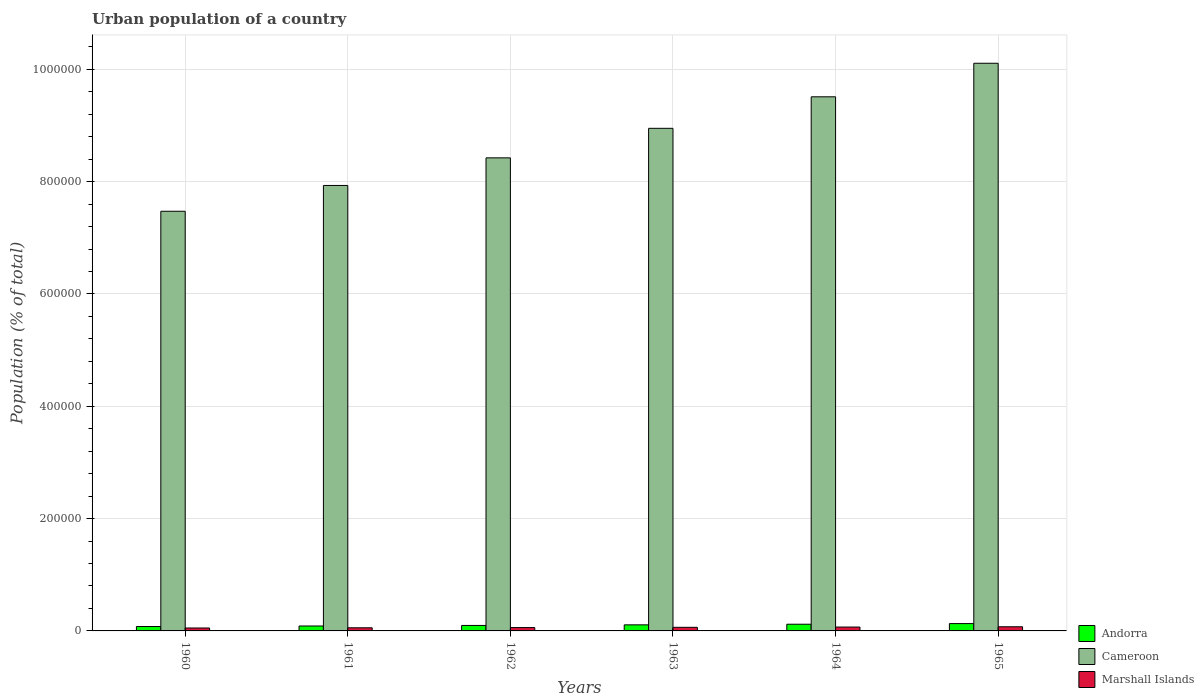How many different coloured bars are there?
Your response must be concise. 3. How many groups of bars are there?
Provide a short and direct response. 6. Are the number of bars per tick equal to the number of legend labels?
Provide a short and direct response. Yes. What is the urban population in Marshall Islands in 1963?
Ensure brevity in your answer.  6408. Across all years, what is the maximum urban population in Andorra?
Your answer should be compact. 1.31e+04. Across all years, what is the minimum urban population in Marshall Islands?
Your answer should be very brief. 5218. In which year was the urban population in Marshall Islands maximum?
Your answer should be compact. 1965. What is the total urban population in Cameroon in the graph?
Offer a very short reply. 5.24e+06. What is the difference between the urban population in Andorra in 1961 and that in 1965?
Keep it short and to the point. -4301. What is the difference between the urban population in Marshall Islands in 1962 and the urban population in Cameroon in 1963?
Offer a terse response. -8.89e+05. What is the average urban population in Andorra per year?
Your answer should be very brief. 1.04e+04. In the year 1961, what is the difference between the urban population in Cameroon and urban population in Marshall Islands?
Make the answer very short. 7.88e+05. In how many years, is the urban population in Andorra greater than 760000 %?
Provide a short and direct response. 0. What is the ratio of the urban population in Marshall Islands in 1960 to that in 1965?
Your response must be concise. 0.71. Is the difference between the urban population in Cameroon in 1962 and 1965 greater than the difference between the urban population in Marshall Islands in 1962 and 1965?
Keep it short and to the point. No. What is the difference between the highest and the second highest urban population in Cameroon?
Ensure brevity in your answer.  5.97e+04. What is the difference between the highest and the lowest urban population in Andorra?
Give a very brief answer. 5228. What does the 3rd bar from the left in 1965 represents?
Provide a short and direct response. Marshall Islands. What does the 2nd bar from the right in 1960 represents?
Your response must be concise. Cameroon. How many years are there in the graph?
Give a very brief answer. 6. What is the difference between two consecutive major ticks on the Y-axis?
Provide a succinct answer. 2.00e+05. Does the graph contain any zero values?
Offer a very short reply. No. Does the graph contain grids?
Your response must be concise. Yes. How many legend labels are there?
Provide a succinct answer. 3. What is the title of the graph?
Make the answer very short. Urban population of a country. What is the label or title of the X-axis?
Offer a very short reply. Years. What is the label or title of the Y-axis?
Your answer should be compact. Population (% of total). What is the Population (% of total) of Andorra in 1960?
Your response must be concise. 7840. What is the Population (% of total) in Cameroon in 1960?
Provide a short and direct response. 7.47e+05. What is the Population (% of total) in Marshall Islands in 1960?
Provide a succinct answer. 5218. What is the Population (% of total) in Andorra in 1961?
Provide a short and direct response. 8767. What is the Population (% of total) in Cameroon in 1961?
Provide a short and direct response. 7.93e+05. What is the Population (% of total) in Marshall Islands in 1961?
Offer a terse response. 5563. What is the Population (% of total) in Andorra in 1962?
Offer a very short reply. 9758. What is the Population (% of total) in Cameroon in 1962?
Keep it short and to the point. 8.42e+05. What is the Population (% of total) in Marshall Islands in 1962?
Your answer should be compact. 5963. What is the Population (% of total) of Andorra in 1963?
Ensure brevity in your answer.  1.08e+04. What is the Population (% of total) of Cameroon in 1963?
Your answer should be compact. 8.95e+05. What is the Population (% of total) in Marshall Islands in 1963?
Make the answer very short. 6408. What is the Population (% of total) of Andorra in 1964?
Your response must be concise. 1.19e+04. What is the Population (% of total) of Cameroon in 1964?
Make the answer very short. 9.51e+05. What is the Population (% of total) in Marshall Islands in 1964?
Provide a short and direct response. 6884. What is the Population (% of total) in Andorra in 1965?
Your response must be concise. 1.31e+04. What is the Population (% of total) of Cameroon in 1965?
Give a very brief answer. 1.01e+06. What is the Population (% of total) in Marshall Islands in 1965?
Your answer should be compact. 7373. Across all years, what is the maximum Population (% of total) in Andorra?
Your answer should be compact. 1.31e+04. Across all years, what is the maximum Population (% of total) of Cameroon?
Give a very brief answer. 1.01e+06. Across all years, what is the maximum Population (% of total) in Marshall Islands?
Provide a short and direct response. 7373. Across all years, what is the minimum Population (% of total) in Andorra?
Ensure brevity in your answer.  7840. Across all years, what is the minimum Population (% of total) of Cameroon?
Your answer should be very brief. 7.47e+05. Across all years, what is the minimum Population (% of total) of Marshall Islands?
Provide a succinct answer. 5218. What is the total Population (% of total) in Andorra in the graph?
Your answer should be very brief. 6.22e+04. What is the total Population (% of total) in Cameroon in the graph?
Your response must be concise. 5.24e+06. What is the total Population (% of total) in Marshall Islands in the graph?
Your answer should be very brief. 3.74e+04. What is the difference between the Population (% of total) of Andorra in 1960 and that in 1961?
Offer a terse response. -927. What is the difference between the Population (% of total) of Cameroon in 1960 and that in 1961?
Keep it short and to the point. -4.59e+04. What is the difference between the Population (% of total) in Marshall Islands in 1960 and that in 1961?
Ensure brevity in your answer.  -345. What is the difference between the Population (% of total) in Andorra in 1960 and that in 1962?
Keep it short and to the point. -1918. What is the difference between the Population (% of total) in Cameroon in 1960 and that in 1962?
Offer a very short reply. -9.51e+04. What is the difference between the Population (% of total) in Marshall Islands in 1960 and that in 1962?
Your response must be concise. -745. What is the difference between the Population (% of total) in Andorra in 1960 and that in 1963?
Make the answer very short. -2970. What is the difference between the Population (% of total) of Cameroon in 1960 and that in 1963?
Offer a very short reply. -1.48e+05. What is the difference between the Population (% of total) of Marshall Islands in 1960 and that in 1963?
Offer a terse response. -1190. What is the difference between the Population (% of total) in Andorra in 1960 and that in 1964?
Provide a short and direct response. -4075. What is the difference between the Population (% of total) of Cameroon in 1960 and that in 1964?
Ensure brevity in your answer.  -2.04e+05. What is the difference between the Population (% of total) of Marshall Islands in 1960 and that in 1964?
Make the answer very short. -1666. What is the difference between the Population (% of total) in Andorra in 1960 and that in 1965?
Give a very brief answer. -5228. What is the difference between the Population (% of total) of Cameroon in 1960 and that in 1965?
Your answer should be very brief. -2.64e+05. What is the difference between the Population (% of total) of Marshall Islands in 1960 and that in 1965?
Offer a very short reply. -2155. What is the difference between the Population (% of total) in Andorra in 1961 and that in 1962?
Provide a short and direct response. -991. What is the difference between the Population (% of total) in Cameroon in 1961 and that in 1962?
Make the answer very short. -4.92e+04. What is the difference between the Population (% of total) of Marshall Islands in 1961 and that in 1962?
Your answer should be very brief. -400. What is the difference between the Population (% of total) in Andorra in 1961 and that in 1963?
Your answer should be compact. -2043. What is the difference between the Population (% of total) in Cameroon in 1961 and that in 1963?
Provide a succinct answer. -1.02e+05. What is the difference between the Population (% of total) in Marshall Islands in 1961 and that in 1963?
Provide a short and direct response. -845. What is the difference between the Population (% of total) of Andorra in 1961 and that in 1964?
Make the answer very short. -3148. What is the difference between the Population (% of total) of Cameroon in 1961 and that in 1964?
Your answer should be very brief. -1.58e+05. What is the difference between the Population (% of total) in Marshall Islands in 1961 and that in 1964?
Give a very brief answer. -1321. What is the difference between the Population (% of total) in Andorra in 1961 and that in 1965?
Your response must be concise. -4301. What is the difference between the Population (% of total) in Cameroon in 1961 and that in 1965?
Provide a short and direct response. -2.18e+05. What is the difference between the Population (% of total) of Marshall Islands in 1961 and that in 1965?
Your answer should be compact. -1810. What is the difference between the Population (% of total) in Andorra in 1962 and that in 1963?
Your response must be concise. -1052. What is the difference between the Population (% of total) of Cameroon in 1962 and that in 1963?
Make the answer very short. -5.26e+04. What is the difference between the Population (% of total) in Marshall Islands in 1962 and that in 1963?
Keep it short and to the point. -445. What is the difference between the Population (% of total) in Andorra in 1962 and that in 1964?
Provide a short and direct response. -2157. What is the difference between the Population (% of total) in Cameroon in 1962 and that in 1964?
Make the answer very short. -1.09e+05. What is the difference between the Population (% of total) of Marshall Islands in 1962 and that in 1964?
Your answer should be very brief. -921. What is the difference between the Population (% of total) in Andorra in 1962 and that in 1965?
Ensure brevity in your answer.  -3310. What is the difference between the Population (% of total) in Cameroon in 1962 and that in 1965?
Your answer should be compact. -1.68e+05. What is the difference between the Population (% of total) of Marshall Islands in 1962 and that in 1965?
Your answer should be very brief. -1410. What is the difference between the Population (% of total) of Andorra in 1963 and that in 1964?
Your response must be concise. -1105. What is the difference between the Population (% of total) in Cameroon in 1963 and that in 1964?
Make the answer very short. -5.61e+04. What is the difference between the Population (% of total) of Marshall Islands in 1963 and that in 1964?
Ensure brevity in your answer.  -476. What is the difference between the Population (% of total) in Andorra in 1963 and that in 1965?
Offer a terse response. -2258. What is the difference between the Population (% of total) of Cameroon in 1963 and that in 1965?
Your response must be concise. -1.16e+05. What is the difference between the Population (% of total) in Marshall Islands in 1963 and that in 1965?
Provide a short and direct response. -965. What is the difference between the Population (% of total) in Andorra in 1964 and that in 1965?
Provide a succinct answer. -1153. What is the difference between the Population (% of total) of Cameroon in 1964 and that in 1965?
Give a very brief answer. -5.97e+04. What is the difference between the Population (% of total) in Marshall Islands in 1964 and that in 1965?
Ensure brevity in your answer.  -489. What is the difference between the Population (% of total) of Andorra in 1960 and the Population (% of total) of Cameroon in 1961?
Keep it short and to the point. -7.85e+05. What is the difference between the Population (% of total) of Andorra in 1960 and the Population (% of total) of Marshall Islands in 1961?
Make the answer very short. 2277. What is the difference between the Population (% of total) in Cameroon in 1960 and the Population (% of total) in Marshall Islands in 1961?
Provide a short and direct response. 7.42e+05. What is the difference between the Population (% of total) in Andorra in 1960 and the Population (% of total) in Cameroon in 1962?
Your answer should be very brief. -8.34e+05. What is the difference between the Population (% of total) in Andorra in 1960 and the Population (% of total) in Marshall Islands in 1962?
Offer a very short reply. 1877. What is the difference between the Population (% of total) in Cameroon in 1960 and the Population (% of total) in Marshall Islands in 1962?
Offer a terse response. 7.41e+05. What is the difference between the Population (% of total) of Andorra in 1960 and the Population (% of total) of Cameroon in 1963?
Make the answer very short. -8.87e+05. What is the difference between the Population (% of total) of Andorra in 1960 and the Population (% of total) of Marshall Islands in 1963?
Keep it short and to the point. 1432. What is the difference between the Population (% of total) of Cameroon in 1960 and the Population (% of total) of Marshall Islands in 1963?
Give a very brief answer. 7.41e+05. What is the difference between the Population (% of total) in Andorra in 1960 and the Population (% of total) in Cameroon in 1964?
Keep it short and to the point. -9.43e+05. What is the difference between the Population (% of total) in Andorra in 1960 and the Population (% of total) in Marshall Islands in 1964?
Your response must be concise. 956. What is the difference between the Population (% of total) in Cameroon in 1960 and the Population (% of total) in Marshall Islands in 1964?
Provide a short and direct response. 7.40e+05. What is the difference between the Population (% of total) in Andorra in 1960 and the Population (% of total) in Cameroon in 1965?
Your answer should be very brief. -1.00e+06. What is the difference between the Population (% of total) of Andorra in 1960 and the Population (% of total) of Marshall Islands in 1965?
Keep it short and to the point. 467. What is the difference between the Population (% of total) of Cameroon in 1960 and the Population (% of total) of Marshall Islands in 1965?
Provide a short and direct response. 7.40e+05. What is the difference between the Population (% of total) of Andorra in 1961 and the Population (% of total) of Cameroon in 1962?
Make the answer very short. -8.34e+05. What is the difference between the Population (% of total) of Andorra in 1961 and the Population (% of total) of Marshall Islands in 1962?
Provide a short and direct response. 2804. What is the difference between the Population (% of total) of Cameroon in 1961 and the Population (% of total) of Marshall Islands in 1962?
Make the answer very short. 7.87e+05. What is the difference between the Population (% of total) of Andorra in 1961 and the Population (% of total) of Cameroon in 1963?
Give a very brief answer. -8.86e+05. What is the difference between the Population (% of total) in Andorra in 1961 and the Population (% of total) in Marshall Islands in 1963?
Offer a terse response. 2359. What is the difference between the Population (% of total) of Cameroon in 1961 and the Population (% of total) of Marshall Islands in 1963?
Offer a terse response. 7.87e+05. What is the difference between the Population (% of total) in Andorra in 1961 and the Population (% of total) in Cameroon in 1964?
Provide a short and direct response. -9.42e+05. What is the difference between the Population (% of total) of Andorra in 1961 and the Population (% of total) of Marshall Islands in 1964?
Provide a short and direct response. 1883. What is the difference between the Population (% of total) in Cameroon in 1961 and the Population (% of total) in Marshall Islands in 1964?
Make the answer very short. 7.86e+05. What is the difference between the Population (% of total) in Andorra in 1961 and the Population (% of total) in Cameroon in 1965?
Give a very brief answer. -1.00e+06. What is the difference between the Population (% of total) of Andorra in 1961 and the Population (% of total) of Marshall Islands in 1965?
Your response must be concise. 1394. What is the difference between the Population (% of total) in Cameroon in 1961 and the Population (% of total) in Marshall Islands in 1965?
Offer a terse response. 7.86e+05. What is the difference between the Population (% of total) in Andorra in 1962 and the Population (% of total) in Cameroon in 1963?
Ensure brevity in your answer.  -8.85e+05. What is the difference between the Population (% of total) of Andorra in 1962 and the Population (% of total) of Marshall Islands in 1963?
Your answer should be very brief. 3350. What is the difference between the Population (% of total) of Cameroon in 1962 and the Population (% of total) of Marshall Islands in 1963?
Ensure brevity in your answer.  8.36e+05. What is the difference between the Population (% of total) in Andorra in 1962 and the Population (% of total) in Cameroon in 1964?
Provide a short and direct response. -9.41e+05. What is the difference between the Population (% of total) of Andorra in 1962 and the Population (% of total) of Marshall Islands in 1964?
Keep it short and to the point. 2874. What is the difference between the Population (% of total) of Cameroon in 1962 and the Population (% of total) of Marshall Islands in 1964?
Make the answer very short. 8.35e+05. What is the difference between the Population (% of total) of Andorra in 1962 and the Population (% of total) of Cameroon in 1965?
Give a very brief answer. -1.00e+06. What is the difference between the Population (% of total) in Andorra in 1962 and the Population (% of total) in Marshall Islands in 1965?
Make the answer very short. 2385. What is the difference between the Population (% of total) of Cameroon in 1962 and the Population (% of total) of Marshall Islands in 1965?
Offer a terse response. 8.35e+05. What is the difference between the Population (% of total) of Andorra in 1963 and the Population (% of total) of Cameroon in 1964?
Give a very brief answer. -9.40e+05. What is the difference between the Population (% of total) of Andorra in 1963 and the Population (% of total) of Marshall Islands in 1964?
Make the answer very short. 3926. What is the difference between the Population (% of total) in Cameroon in 1963 and the Population (% of total) in Marshall Islands in 1964?
Offer a very short reply. 8.88e+05. What is the difference between the Population (% of total) of Andorra in 1963 and the Population (% of total) of Cameroon in 1965?
Give a very brief answer. -1.00e+06. What is the difference between the Population (% of total) of Andorra in 1963 and the Population (% of total) of Marshall Islands in 1965?
Your answer should be compact. 3437. What is the difference between the Population (% of total) in Cameroon in 1963 and the Population (% of total) in Marshall Islands in 1965?
Your response must be concise. 8.88e+05. What is the difference between the Population (% of total) of Andorra in 1964 and the Population (% of total) of Cameroon in 1965?
Offer a terse response. -9.99e+05. What is the difference between the Population (% of total) in Andorra in 1964 and the Population (% of total) in Marshall Islands in 1965?
Provide a succinct answer. 4542. What is the difference between the Population (% of total) of Cameroon in 1964 and the Population (% of total) of Marshall Islands in 1965?
Make the answer very short. 9.44e+05. What is the average Population (% of total) in Andorra per year?
Give a very brief answer. 1.04e+04. What is the average Population (% of total) in Cameroon per year?
Give a very brief answer. 8.73e+05. What is the average Population (% of total) of Marshall Islands per year?
Provide a short and direct response. 6234.83. In the year 1960, what is the difference between the Population (% of total) of Andorra and Population (% of total) of Cameroon?
Your answer should be very brief. -7.39e+05. In the year 1960, what is the difference between the Population (% of total) of Andorra and Population (% of total) of Marshall Islands?
Give a very brief answer. 2622. In the year 1960, what is the difference between the Population (% of total) of Cameroon and Population (% of total) of Marshall Islands?
Provide a short and direct response. 7.42e+05. In the year 1961, what is the difference between the Population (% of total) in Andorra and Population (% of total) in Cameroon?
Your response must be concise. -7.84e+05. In the year 1961, what is the difference between the Population (% of total) of Andorra and Population (% of total) of Marshall Islands?
Your response must be concise. 3204. In the year 1961, what is the difference between the Population (% of total) of Cameroon and Population (% of total) of Marshall Islands?
Your answer should be very brief. 7.88e+05. In the year 1962, what is the difference between the Population (% of total) of Andorra and Population (% of total) of Cameroon?
Provide a succinct answer. -8.33e+05. In the year 1962, what is the difference between the Population (% of total) in Andorra and Population (% of total) in Marshall Islands?
Ensure brevity in your answer.  3795. In the year 1962, what is the difference between the Population (% of total) of Cameroon and Population (% of total) of Marshall Islands?
Your response must be concise. 8.36e+05. In the year 1963, what is the difference between the Population (% of total) of Andorra and Population (% of total) of Cameroon?
Your answer should be compact. -8.84e+05. In the year 1963, what is the difference between the Population (% of total) of Andorra and Population (% of total) of Marshall Islands?
Make the answer very short. 4402. In the year 1963, what is the difference between the Population (% of total) in Cameroon and Population (% of total) in Marshall Islands?
Offer a terse response. 8.88e+05. In the year 1964, what is the difference between the Population (% of total) in Andorra and Population (% of total) in Cameroon?
Keep it short and to the point. -9.39e+05. In the year 1964, what is the difference between the Population (% of total) of Andorra and Population (% of total) of Marshall Islands?
Your answer should be compact. 5031. In the year 1964, what is the difference between the Population (% of total) in Cameroon and Population (% of total) in Marshall Islands?
Ensure brevity in your answer.  9.44e+05. In the year 1965, what is the difference between the Population (% of total) in Andorra and Population (% of total) in Cameroon?
Offer a terse response. -9.98e+05. In the year 1965, what is the difference between the Population (% of total) in Andorra and Population (% of total) in Marshall Islands?
Your answer should be compact. 5695. In the year 1965, what is the difference between the Population (% of total) in Cameroon and Population (% of total) in Marshall Islands?
Provide a short and direct response. 1.00e+06. What is the ratio of the Population (% of total) in Andorra in 1960 to that in 1961?
Provide a succinct answer. 0.89. What is the ratio of the Population (% of total) in Cameroon in 1960 to that in 1961?
Your answer should be compact. 0.94. What is the ratio of the Population (% of total) of Marshall Islands in 1960 to that in 1961?
Your answer should be very brief. 0.94. What is the ratio of the Population (% of total) in Andorra in 1960 to that in 1962?
Provide a short and direct response. 0.8. What is the ratio of the Population (% of total) in Cameroon in 1960 to that in 1962?
Offer a very short reply. 0.89. What is the ratio of the Population (% of total) in Marshall Islands in 1960 to that in 1962?
Give a very brief answer. 0.88. What is the ratio of the Population (% of total) in Andorra in 1960 to that in 1963?
Give a very brief answer. 0.73. What is the ratio of the Population (% of total) of Cameroon in 1960 to that in 1963?
Offer a terse response. 0.83. What is the ratio of the Population (% of total) in Marshall Islands in 1960 to that in 1963?
Provide a short and direct response. 0.81. What is the ratio of the Population (% of total) of Andorra in 1960 to that in 1964?
Ensure brevity in your answer.  0.66. What is the ratio of the Population (% of total) in Cameroon in 1960 to that in 1964?
Your answer should be very brief. 0.79. What is the ratio of the Population (% of total) of Marshall Islands in 1960 to that in 1964?
Make the answer very short. 0.76. What is the ratio of the Population (% of total) of Andorra in 1960 to that in 1965?
Your answer should be very brief. 0.6. What is the ratio of the Population (% of total) in Cameroon in 1960 to that in 1965?
Provide a succinct answer. 0.74. What is the ratio of the Population (% of total) of Marshall Islands in 1960 to that in 1965?
Ensure brevity in your answer.  0.71. What is the ratio of the Population (% of total) in Andorra in 1961 to that in 1962?
Your response must be concise. 0.9. What is the ratio of the Population (% of total) in Cameroon in 1961 to that in 1962?
Your answer should be very brief. 0.94. What is the ratio of the Population (% of total) in Marshall Islands in 1961 to that in 1962?
Ensure brevity in your answer.  0.93. What is the ratio of the Population (% of total) in Andorra in 1961 to that in 1963?
Keep it short and to the point. 0.81. What is the ratio of the Population (% of total) of Cameroon in 1961 to that in 1963?
Make the answer very short. 0.89. What is the ratio of the Population (% of total) in Marshall Islands in 1961 to that in 1963?
Keep it short and to the point. 0.87. What is the ratio of the Population (% of total) of Andorra in 1961 to that in 1964?
Your answer should be compact. 0.74. What is the ratio of the Population (% of total) of Cameroon in 1961 to that in 1964?
Your answer should be compact. 0.83. What is the ratio of the Population (% of total) of Marshall Islands in 1961 to that in 1964?
Give a very brief answer. 0.81. What is the ratio of the Population (% of total) in Andorra in 1961 to that in 1965?
Your response must be concise. 0.67. What is the ratio of the Population (% of total) of Cameroon in 1961 to that in 1965?
Offer a terse response. 0.78. What is the ratio of the Population (% of total) in Marshall Islands in 1961 to that in 1965?
Give a very brief answer. 0.75. What is the ratio of the Population (% of total) of Andorra in 1962 to that in 1963?
Keep it short and to the point. 0.9. What is the ratio of the Population (% of total) of Cameroon in 1962 to that in 1963?
Provide a succinct answer. 0.94. What is the ratio of the Population (% of total) of Marshall Islands in 1962 to that in 1963?
Offer a terse response. 0.93. What is the ratio of the Population (% of total) of Andorra in 1962 to that in 1964?
Give a very brief answer. 0.82. What is the ratio of the Population (% of total) of Cameroon in 1962 to that in 1964?
Ensure brevity in your answer.  0.89. What is the ratio of the Population (% of total) of Marshall Islands in 1962 to that in 1964?
Your answer should be compact. 0.87. What is the ratio of the Population (% of total) in Andorra in 1962 to that in 1965?
Give a very brief answer. 0.75. What is the ratio of the Population (% of total) of Cameroon in 1962 to that in 1965?
Your response must be concise. 0.83. What is the ratio of the Population (% of total) in Marshall Islands in 1962 to that in 1965?
Provide a short and direct response. 0.81. What is the ratio of the Population (% of total) in Andorra in 1963 to that in 1964?
Offer a terse response. 0.91. What is the ratio of the Population (% of total) of Cameroon in 1963 to that in 1964?
Make the answer very short. 0.94. What is the ratio of the Population (% of total) in Marshall Islands in 1963 to that in 1964?
Your answer should be compact. 0.93. What is the ratio of the Population (% of total) of Andorra in 1963 to that in 1965?
Ensure brevity in your answer.  0.83. What is the ratio of the Population (% of total) in Cameroon in 1963 to that in 1965?
Make the answer very short. 0.89. What is the ratio of the Population (% of total) in Marshall Islands in 1963 to that in 1965?
Your answer should be very brief. 0.87. What is the ratio of the Population (% of total) of Andorra in 1964 to that in 1965?
Keep it short and to the point. 0.91. What is the ratio of the Population (% of total) of Cameroon in 1964 to that in 1965?
Your answer should be very brief. 0.94. What is the ratio of the Population (% of total) of Marshall Islands in 1964 to that in 1965?
Offer a very short reply. 0.93. What is the difference between the highest and the second highest Population (% of total) of Andorra?
Provide a short and direct response. 1153. What is the difference between the highest and the second highest Population (% of total) of Cameroon?
Your answer should be very brief. 5.97e+04. What is the difference between the highest and the second highest Population (% of total) of Marshall Islands?
Offer a terse response. 489. What is the difference between the highest and the lowest Population (% of total) in Andorra?
Provide a succinct answer. 5228. What is the difference between the highest and the lowest Population (% of total) in Cameroon?
Provide a succinct answer. 2.64e+05. What is the difference between the highest and the lowest Population (% of total) of Marshall Islands?
Give a very brief answer. 2155. 